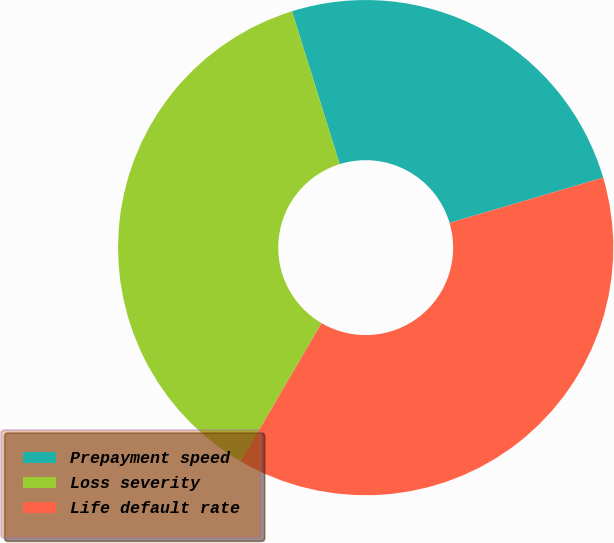<chart> <loc_0><loc_0><loc_500><loc_500><pie_chart><fcel>Prepayment speed<fcel>Loss severity<fcel>Life default rate<nl><fcel>25.25%<fcel>36.77%<fcel>37.98%<nl></chart> 